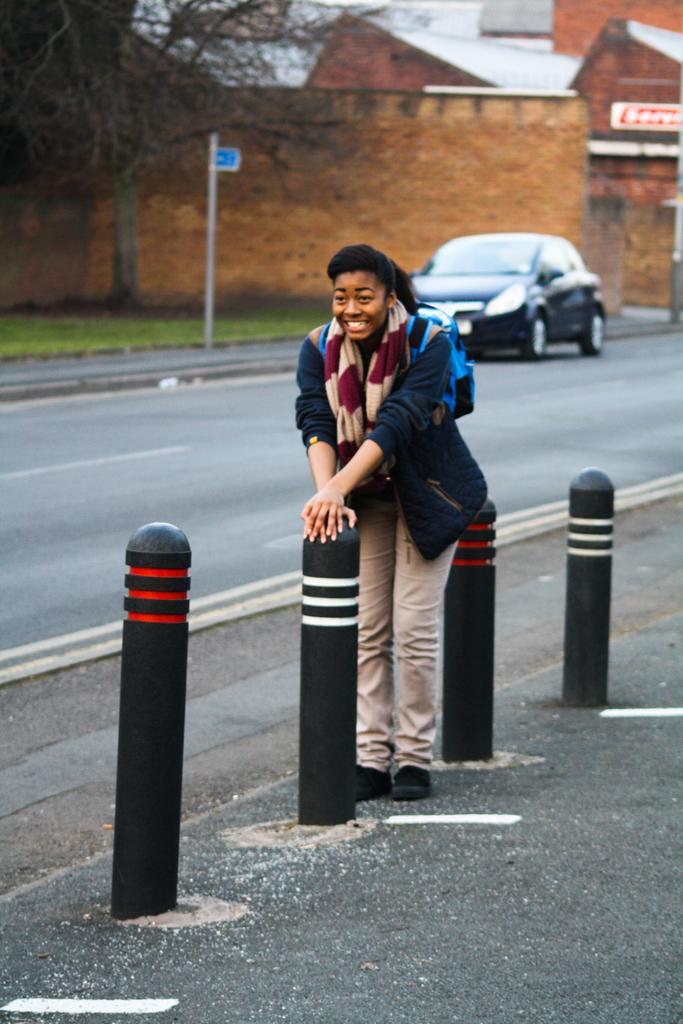In one or two sentences, can you explain what this image depicts? In the foreground of this image, there is a woman standing on the side path and there are few bollards. In the background, there is a vehicle moving on the road, sign board, a wall and few buildings. 